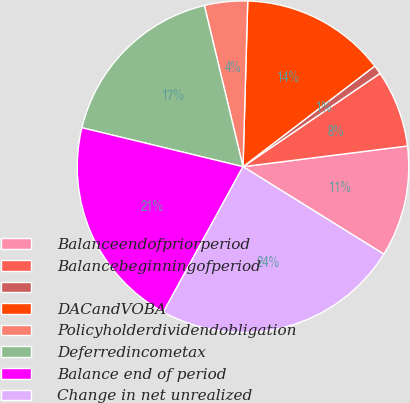Convert chart to OTSL. <chart><loc_0><loc_0><loc_500><loc_500><pie_chart><fcel>Balanceendofpriorperiod<fcel>Balancebeginningofperiod<fcel>Unnamed: 2<fcel>DACandVOBA<fcel>Policyholderdividendobligation<fcel>Deferredincometax<fcel>Balance end of period<fcel>Change in net unrealized<nl><fcel>10.84%<fcel>7.52%<fcel>0.87%<fcel>14.16%<fcel>4.2%<fcel>17.48%<fcel>20.8%<fcel>24.13%<nl></chart> 